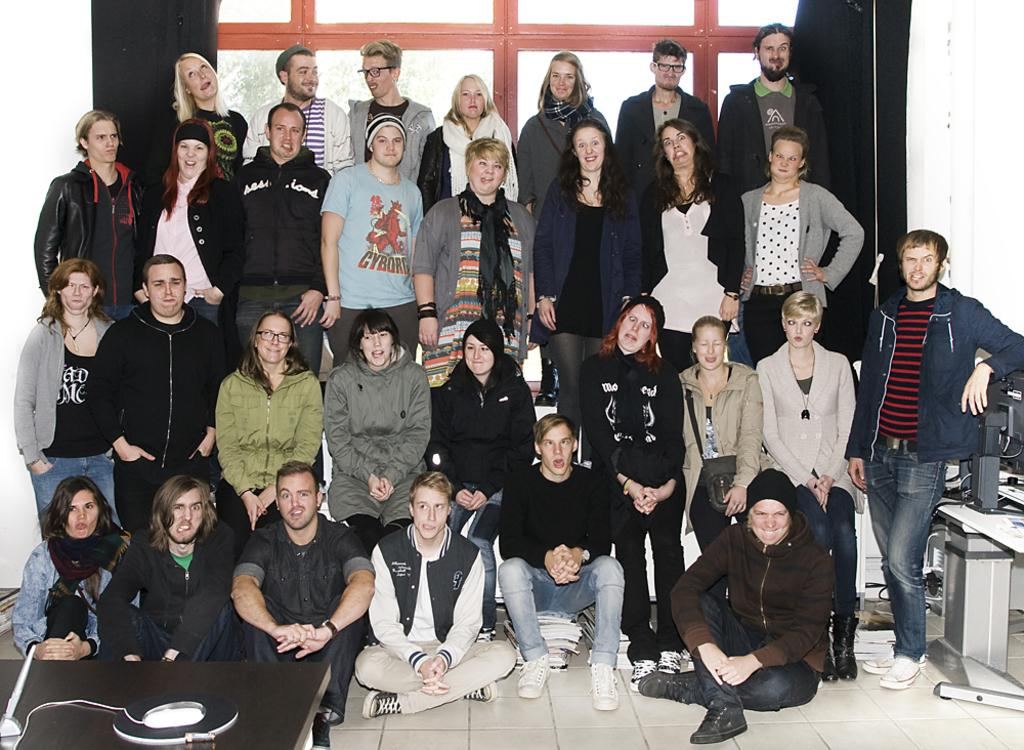How many people are in the image? There is a group of people in the image. What can be observed about the clothing of the people in the image? The people are wearing different color dresses. What can be seen on the tables in the image? There are objects on the tables in the image. What is visible in the background of the image? There are trees and a window visible in the background. What type of insect can be seen crawling on the page in the image? There is no page or insect present in the image. 